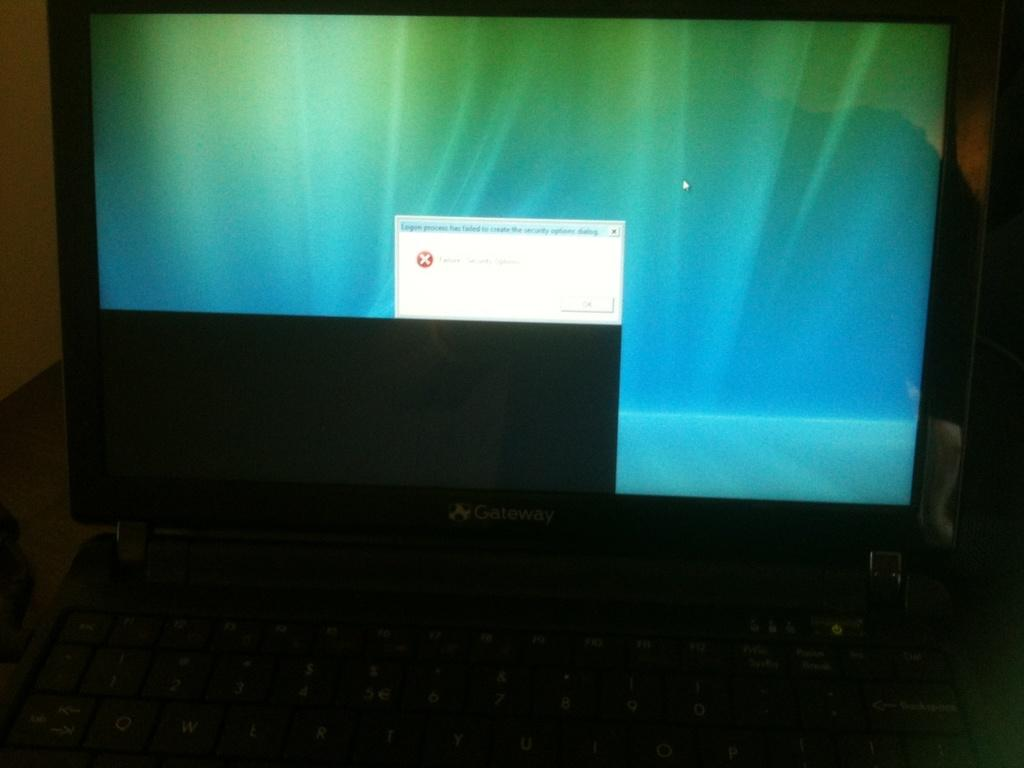What electronic device is visible in the image? There is a laptop in the image. Where is the laptop located? The laptop is placed on a table. Is there a throne visible in the image? No, there is no throne present in the image. 